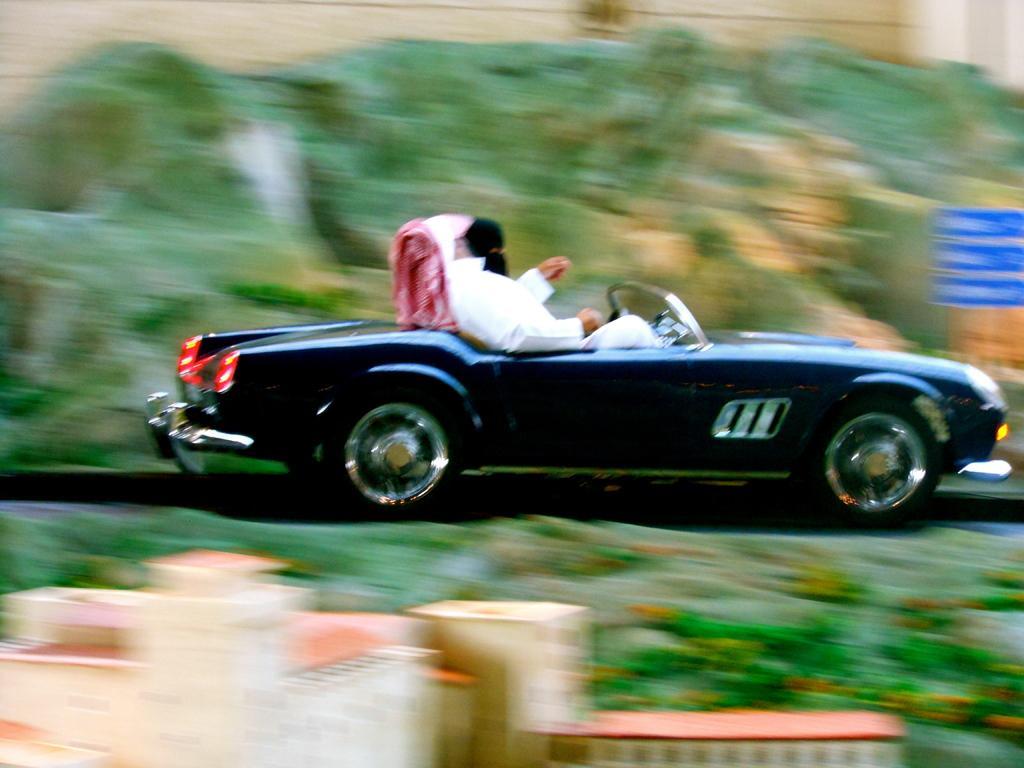Describe this image in one or two sentences. In this picture I can see couple of them sitting in the car and I can see buildings, trees and few boards with some text. 